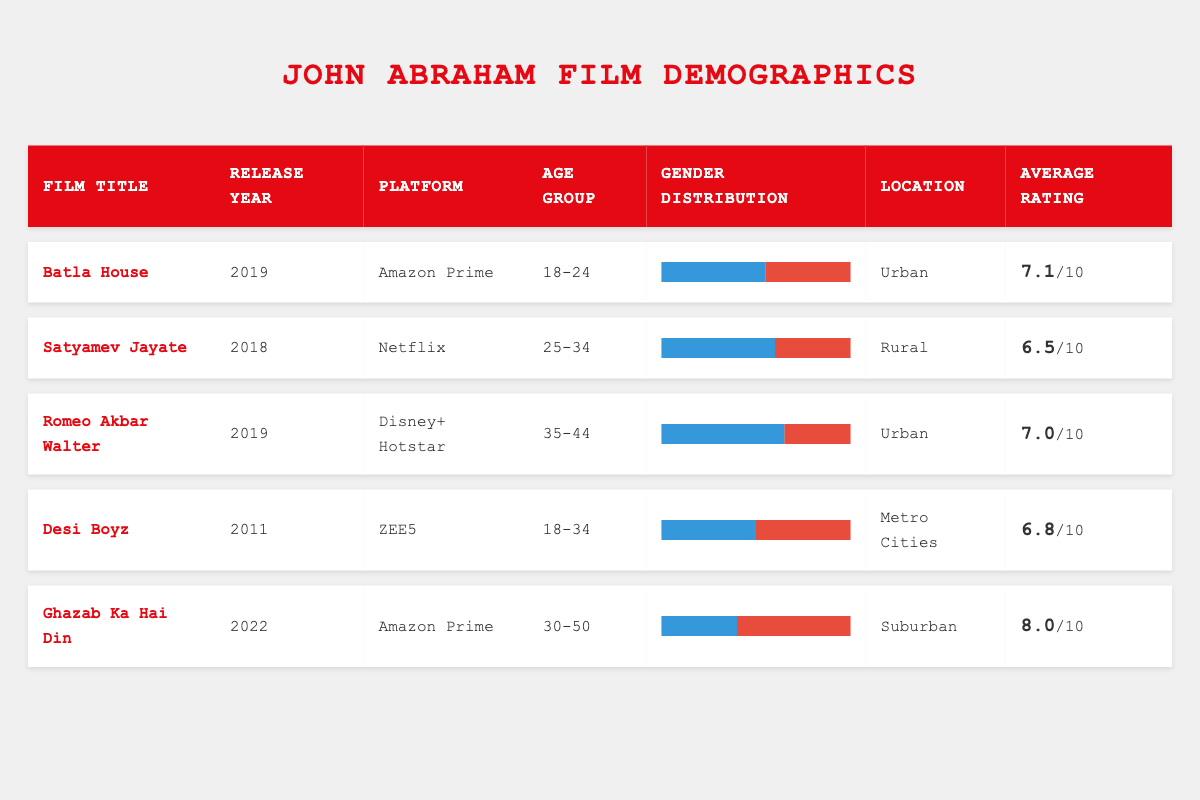What is the average rating of John Abraham's films on Amazon Prime? The films available on Amazon Prime are "Batla House" with a rating of 7.1 and "Ghazab Ka Hai Din" with a rating of 8.0. To find the average rating, we add these ratings together: 7.1 + 8.0 = 15.1. Then, we divide by the number of films (2), which gives us 15.1 / 2 = 7.55.
Answer: 7.55 Which age group has the highest male viewership in John Abraham's films? The viewership data indicates that "Romeo Akbar Walter" has the highest male distribution at 65% in the age group 35-44. This is higher than any other age group in the provided films.
Answer: 35-44 Is the average rating of John Abraham's film "Desi Boyz" higher than that of "Satyamev Jayate"? "Desi Boyz" has an average rating of 6.8 and "Satyamev Jayate" has a rating of 6.5. Since 6.8 is greater than 6.5, the statement is true.
Answer: Yes How does the gender distribution compare between "Ghazab Ka Hai Din" and "Batla House"? "Ghazab Ka Hai Din" has a gender distribution of 40% male and 60% female, while "Batla House" has 55% male and 45% female. We can see that "Batla House" has a higher male percentage (55% vs. 40%) and a lower female percentage (45% vs. 60%).
Answer: Batla House has a higher male percentage What is the percentage of female viewers in the film "Romeo Akbar Walter"? The gender distribution for "Romeo Akbar Walter" states that 35% of the viewers are female. This information is retrieved directly from the table without any additional calculations.
Answer: 35% Which film has the highest average rating, and what is that rating? Among the films listed, "Ghazab Ka Hai Din" has the highest average rating of 8.0, as shown in the table. This is higher than all other average ratings in the data.
Answer: 8.0 